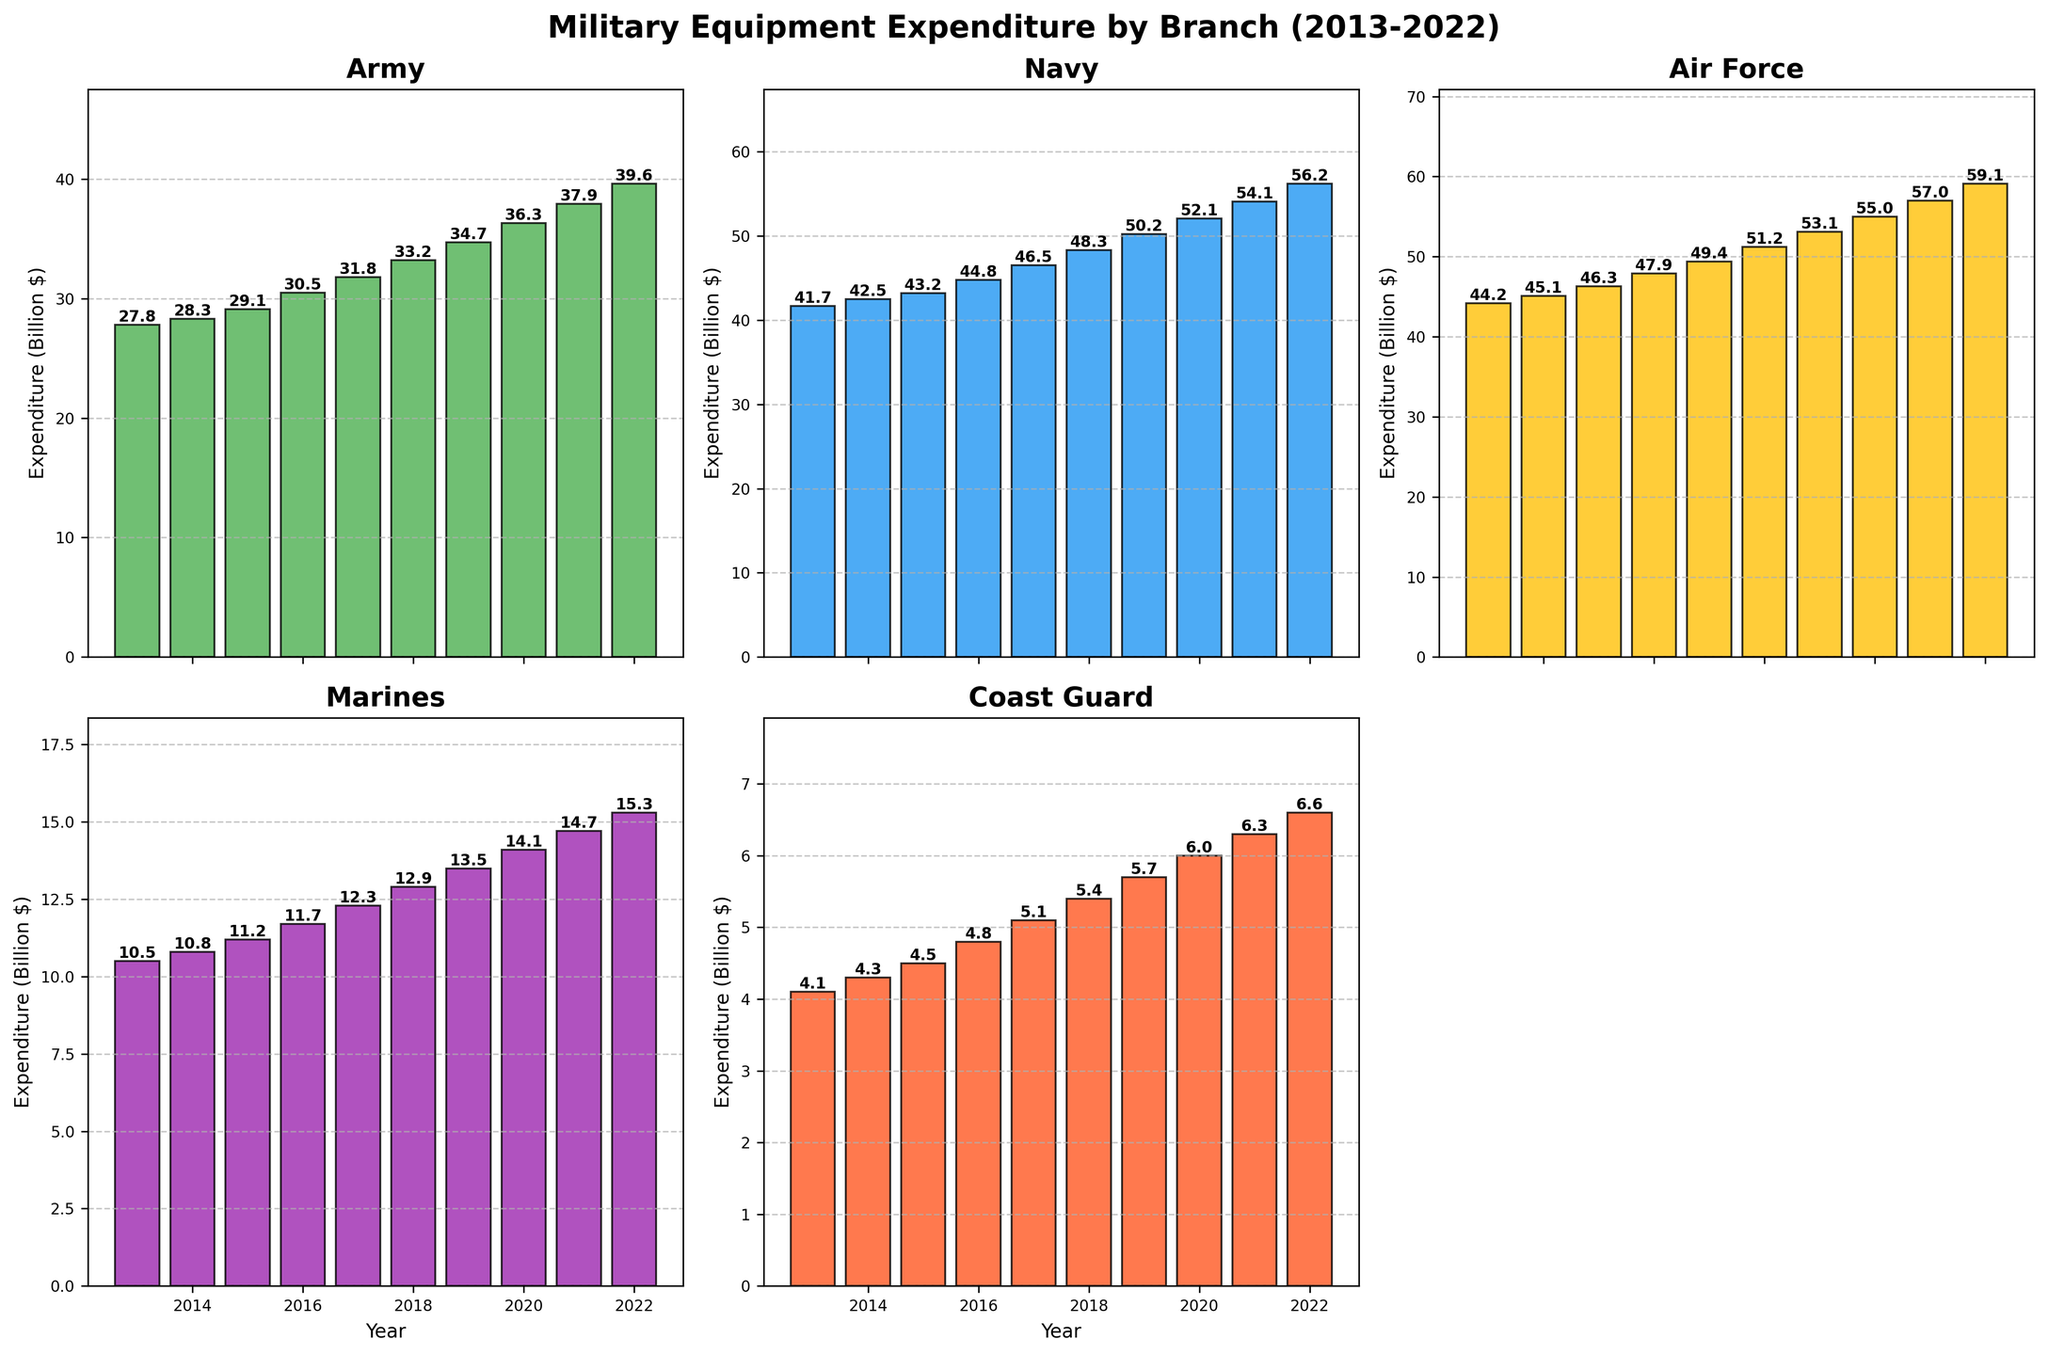What's the highest expenditure for the Army from 2013 to 2022? To find the highest expenditure, look at the Army's bar in each year's subplot. The highest expenditure for the Army is in 2022 with an expenditure of 39.6 billion dollars.
Answer: 39.6 billion dollars Which branch has the lowest overall expenditure in 2019? By observing the height of the bars in 2019, the Coast Guard has the lowest expenditure compared to the other branches with an expenditure of 5.7 billion dollars.
Answer: Coast Guard What is the total expenditure of all branches in 2018? Sum the expenditures of all branches in 2018: Army (33.2) + Navy (48.3) + Air Force (51.2) + Marines (12.9) + Coast Guard (5.4). So, 33.2 + 48.3 + 51.2 + 12.9 + 5.4 = 151.
Answer: 151 billion dollars By how much did the Air Force's expenditure increase from 2013 to 2022? Subtract the expenditure of the Air Force in 2013 from its expenditure in 2022: 59.1 - 44.2. So, 59.1 - 44.2 = 14.9.
Answer: 14.9 billion dollars Which branch had the most significant increase in expenditure from 2013 to 2022? Calculate the increase for each branch from 2013 to 2022: Army (39.6 - 27.8 = 11.8), Navy (56.2 - 41.7 = 14.5), Air Force (59.1 - 44.2 = 14.9), Marines (15.3 - 10.5 = 4.8), Coast Guard (6.6 - 4.1 = 2.5). The Air Force had the most significant increase of 14.9 billion dollars.
Answer: Air Force What was the average annual expenditure for the Marines from 2018 to 2021? Average expenditure is the sum of expenditures from 2018 to 2021 divided by the number of years. Sum: 12.9 (2018) + 13.5 (2019) + 14.1 (2020) + 14.7 (2021) = 55.2. Average: 55.2 / 4 = 13.8.
Answer: 13.8 billion dollars In which year did the Navy surpass 50 billion dollars in expenditure? Observing the Navy's expenditures each year, it first surpasses 50 billion dollars in 2019 with an expenditure of 50.2 billion dollars.
Answer: 2019 How much more did the Air Force spend compared to the Marines in 2020? Subtract the Marine's expenditure from the Air Force's in 2020: 55.0 - 14.1. So, 55.0 - 14.1 = 40.9.
Answer: 40.9 billion dollars Which branch had the highest relative increase in expenditure between 2017 and 2018? Calculate the relative increase: (New - Old) / Old for each branch. Army: (33.2 - 31.8) / 31.8 = 0.044, Navy: (48.3 - 46.5) / 46.5 = 0.039, Air Force: (51.2 - 49.4) / 49.4 = 0.036, Marines: (12.9 - 12.3) / 12.3 = 0.049, Coast Guard: (5.4 - 5.1) / 5.1 = 0.059. Coast Guard had the highest relative increase of approximately 5.9%.
Answer: Coast Guard 